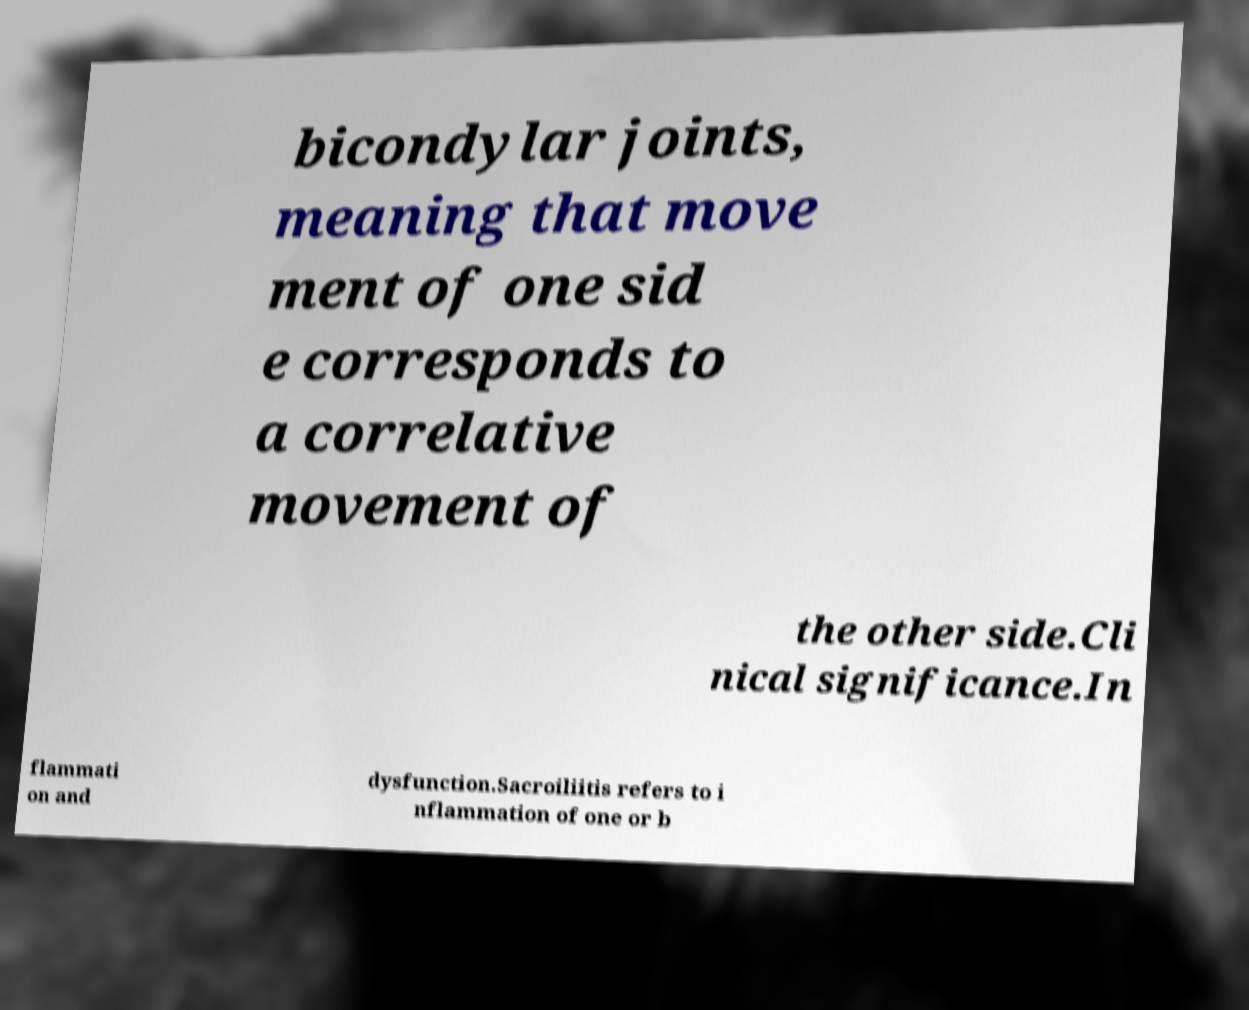I need the written content from this picture converted into text. Can you do that? bicondylar joints, meaning that move ment of one sid e corresponds to a correlative movement of the other side.Cli nical significance.In flammati on and dysfunction.Sacroiliitis refers to i nflammation of one or b 